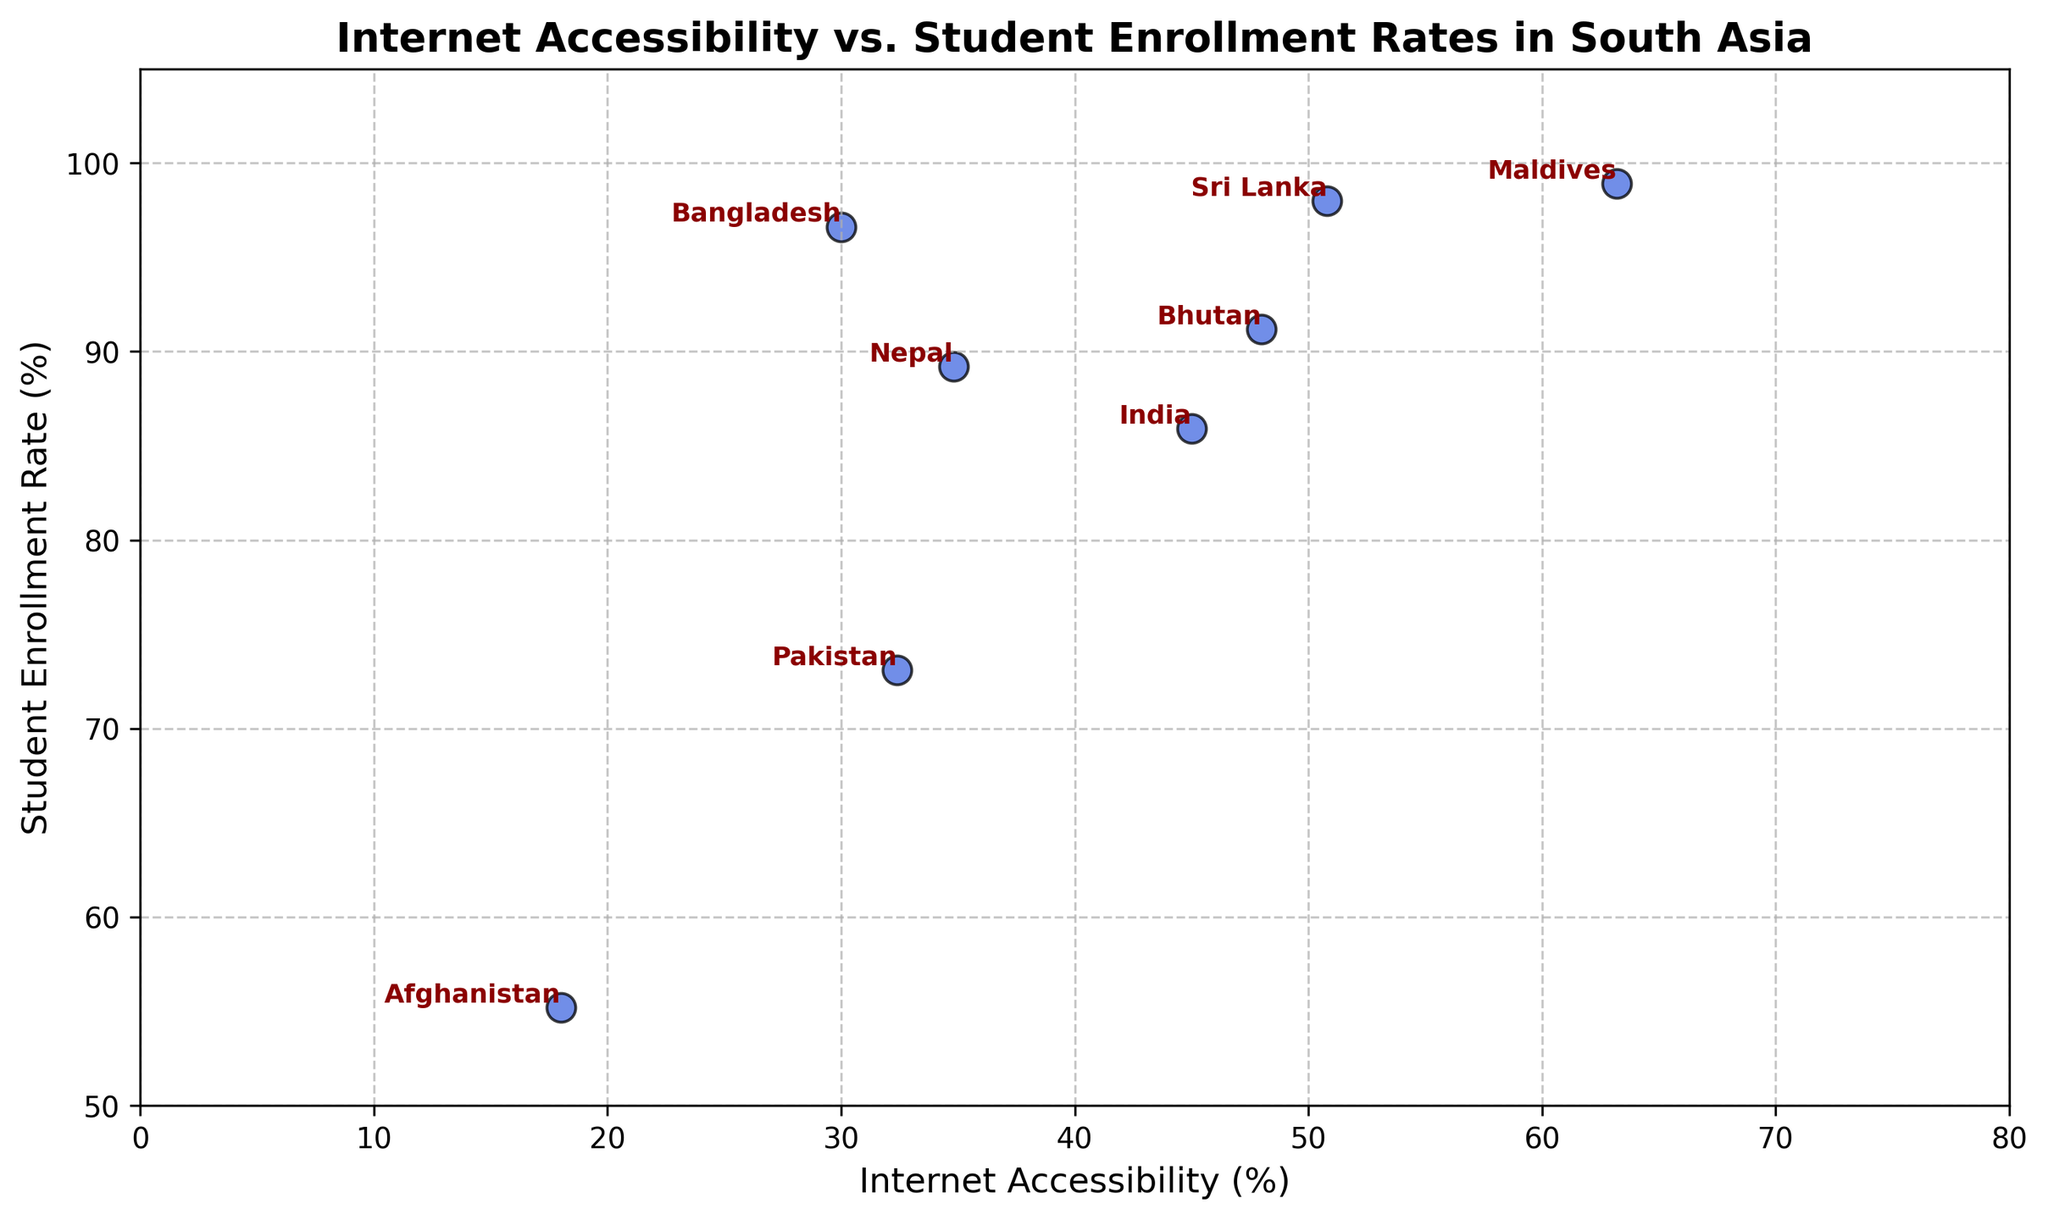What percentage of internet accessibility does Maldives have? We identify Maldives on the plot and read the corresponding value on the x-axis.
Answer: 63.2% Which country has the highest student enrollment rate? Look for the country with the highest position on the y-axis.
Answer: Maldives What is the difference in internet accessibility between Bhutan and Bangladesh? Locate Bhutan and Bangladesh on the x-axis and subtract Bangladesh's internet accessibility from Bhutan's. (48.0% - 30.0%)
Answer: 18% Is there a country with over 50% internet accessibility and more than 90% student enrollment rate? Check the upper regions of both the x-axis and y-axis for the country data.
Answer: Yes, Sri Lanka and Maldives How many countries have an internet accessibility lower than 35%? Count the number of countries below 35% on the x-axis.
Answer: 4 (Afghanistan, Bangladesh, Nepal, Pakistan) Which country has the smallest gap between internet accessibility and student enrollment rate? Calculate the differences for each country and compare.
Answer: Bhutan Comparing India and Pakistan, which country has both higher internet accessibility and student enrollment rate? Compare the positions of India and Pakistan on both axes.
Answer: India Which country with more than 45% student enrollment rate has the lowest internet accessibility? Check countries above 45% enrollment on the x-axis and find the lowest value on the x-axis.
Answer: Afghanistan What is the average student enrollment rate for countries with more than 40% internet accessibility? Identify countries with over 40% internet accessibility and calculate the average of their student enrollment rates ([91.2 + 85.9 + 98.9 + 89.2 + 98.0] / 5).
Answer: 92.64% Does Nepal have higher or lower internet accessibility compared to the regional average? Calculate the regional average internet accessibility and compare Nepal's value (average of [18.0, 30.0, 48.0, 45.0, 63.2, 34.8, 32.4, 50.8] = 40.3%).
Answer: Higher 